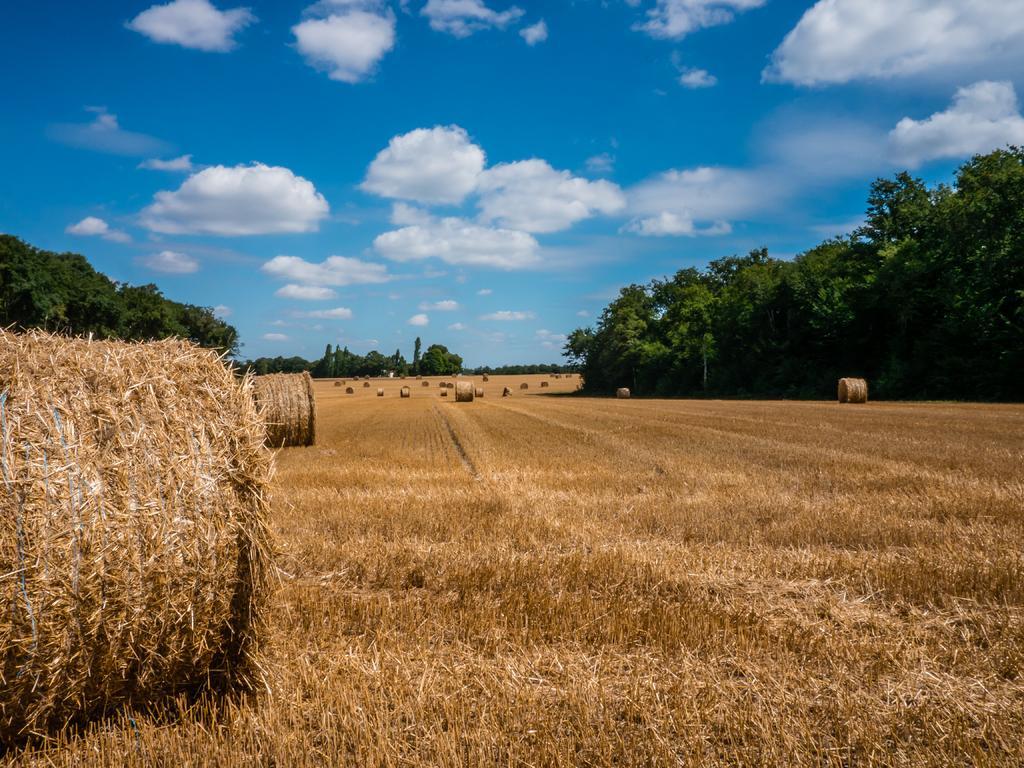How would you summarize this image in a sentence or two? In this image I can see the dried grass, background I can see few trees in green color and the sky is in blue and white color and I can also see few grass rolls. 